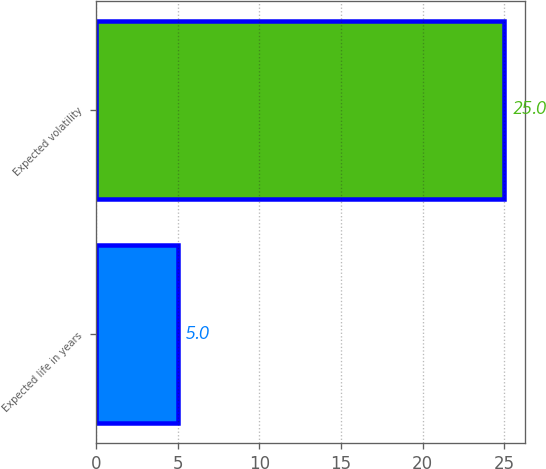Convert chart to OTSL. <chart><loc_0><loc_0><loc_500><loc_500><bar_chart><fcel>Expected life in years<fcel>Expected volatility<nl><fcel>5<fcel>25<nl></chart> 